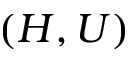Convert formula to latex. <formula><loc_0><loc_0><loc_500><loc_500>( H , U )</formula> 